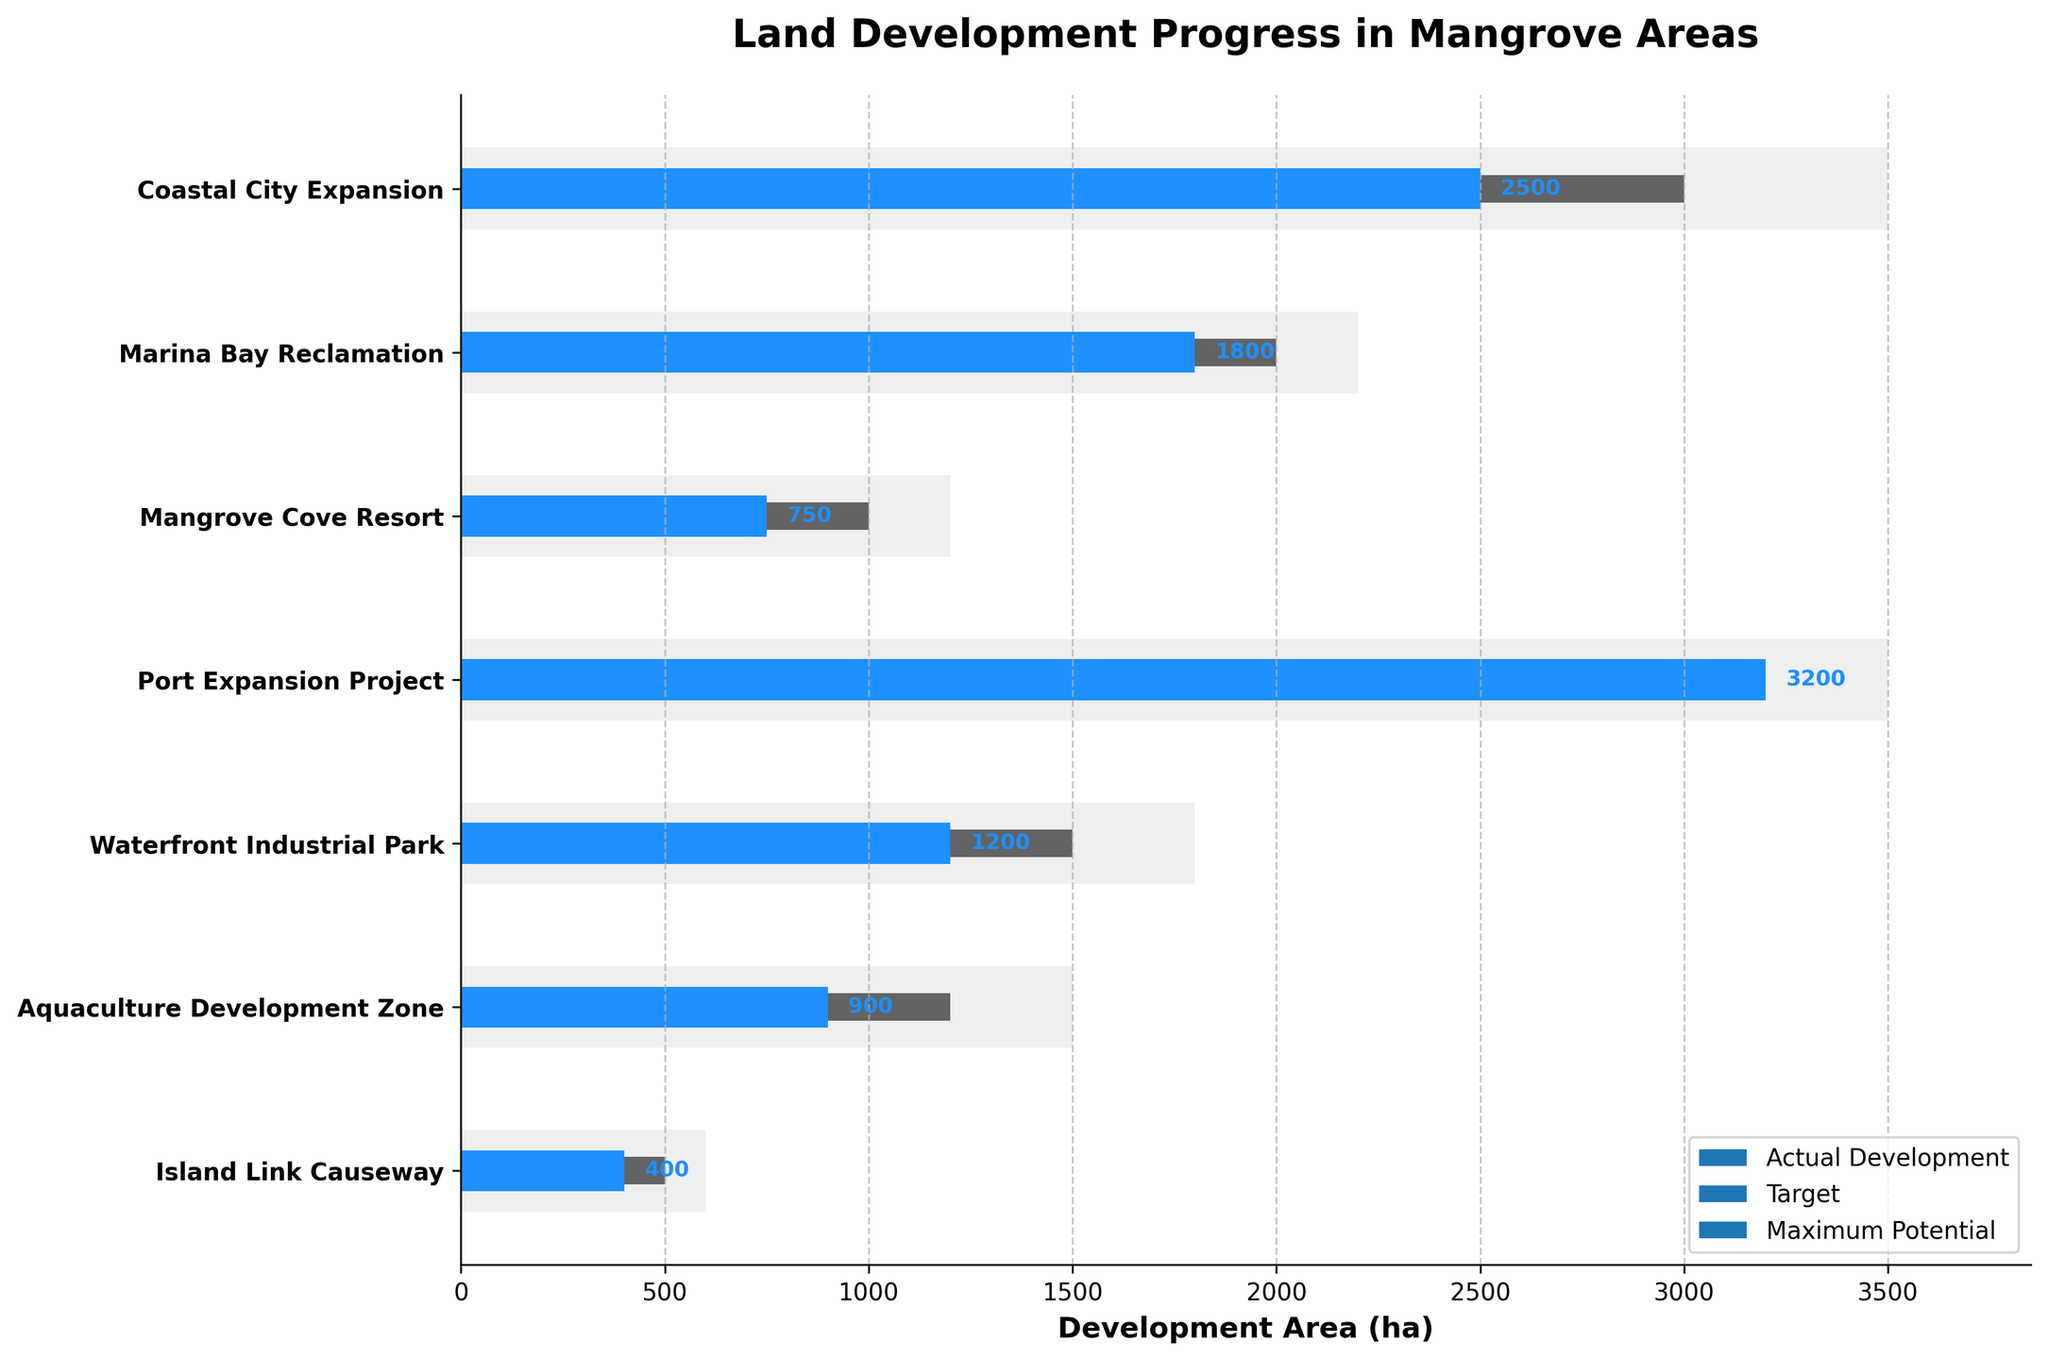What's the title of the chart? The title of the chart is shown at the top and it helps in understanding the focus of the data being presented in the figure.
Answer: Land Development Progress in Mangrove Areas What does the longest bar represent? The longest bar represents the maximum potential for the Port Expansion Project, which appears to be the bar that extends the furthest to the right in the chart.
Answer: Port Expansion Project Which project has achieved its target? By comparing the actual development bars (blue) to the target lines (dark grey), the Port Expansion Project's actual development bar has reached and surpassed its target line.
Answer: Port Expansion Project How many projects have exceeded their target development areas? We need to compare the blue bars with the dark grey lines for each project. The Port Expansion Project and Coastal City Expansion's blue bars exceed their respective grey lines.
Answer: 2 What's the difference between the maximum potential and target development for the Marina Bay Reclamation project? The maximum potential is 2200 ha and the target is 2000 ha. The difference is calculated as 2200 - 2000 = 200.
Answer: 200 ha Which project has the smallest actual development compared to its target? We need to compare the difference between the actual and target values for each project. The Island Link Causeway has the smallest blue bar relative to its grey line, meaning it falls the shortest.
Answer: Island Link Causeway How much more area needs to be developed for the Waterfront Industrial Park to meet its target? The target for the Waterfront Industrial Park is 1500 ha, and the actual is 1200 ha. The difference is 1500 - 1200 = 300.
Answer: 300 ha Which project has the smallest maximum potential development area? The smallest maximum potential is identified by the shortest light grey bar, which is the Island Link Causeway at 600 ha.
Answer: Island Link Causeway What is the total actual development area across all projects? Sum the actual development areas: 2500 + 1800 + 750 + 3200 + 1200 + 900 + 400 = 10750.
Answer: 10750 ha How much more has the Port Expansion Project developed compared to the Mangrove Cove Resort? The actual development area for the Port Expansion Project is 3200 ha and for the Mangrove Cove Resort is 750 ha. The difference is 3200 - 750 = 2450.
Answer: 2450 ha 